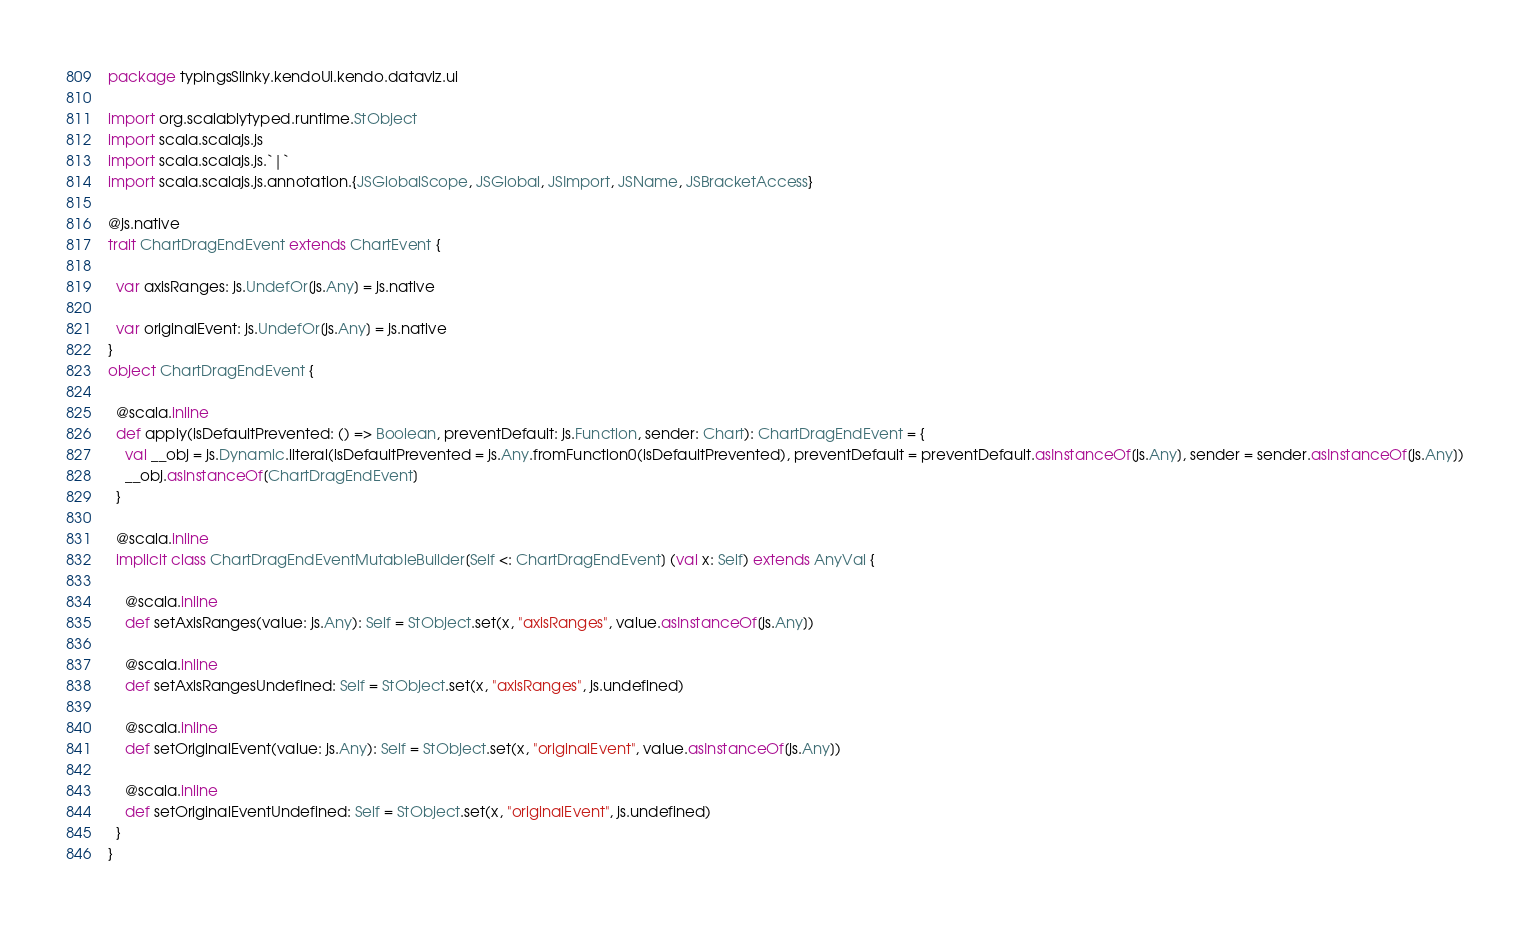<code> <loc_0><loc_0><loc_500><loc_500><_Scala_>package typingsSlinky.kendoUi.kendo.dataviz.ui

import org.scalablytyped.runtime.StObject
import scala.scalajs.js
import scala.scalajs.js.`|`
import scala.scalajs.js.annotation.{JSGlobalScope, JSGlobal, JSImport, JSName, JSBracketAccess}

@js.native
trait ChartDragEndEvent extends ChartEvent {
  
  var axisRanges: js.UndefOr[js.Any] = js.native
  
  var originalEvent: js.UndefOr[js.Any] = js.native
}
object ChartDragEndEvent {
  
  @scala.inline
  def apply(isDefaultPrevented: () => Boolean, preventDefault: js.Function, sender: Chart): ChartDragEndEvent = {
    val __obj = js.Dynamic.literal(isDefaultPrevented = js.Any.fromFunction0(isDefaultPrevented), preventDefault = preventDefault.asInstanceOf[js.Any], sender = sender.asInstanceOf[js.Any])
    __obj.asInstanceOf[ChartDragEndEvent]
  }
  
  @scala.inline
  implicit class ChartDragEndEventMutableBuilder[Self <: ChartDragEndEvent] (val x: Self) extends AnyVal {
    
    @scala.inline
    def setAxisRanges(value: js.Any): Self = StObject.set(x, "axisRanges", value.asInstanceOf[js.Any])
    
    @scala.inline
    def setAxisRangesUndefined: Self = StObject.set(x, "axisRanges", js.undefined)
    
    @scala.inline
    def setOriginalEvent(value: js.Any): Self = StObject.set(x, "originalEvent", value.asInstanceOf[js.Any])
    
    @scala.inline
    def setOriginalEventUndefined: Self = StObject.set(x, "originalEvent", js.undefined)
  }
}
</code> 